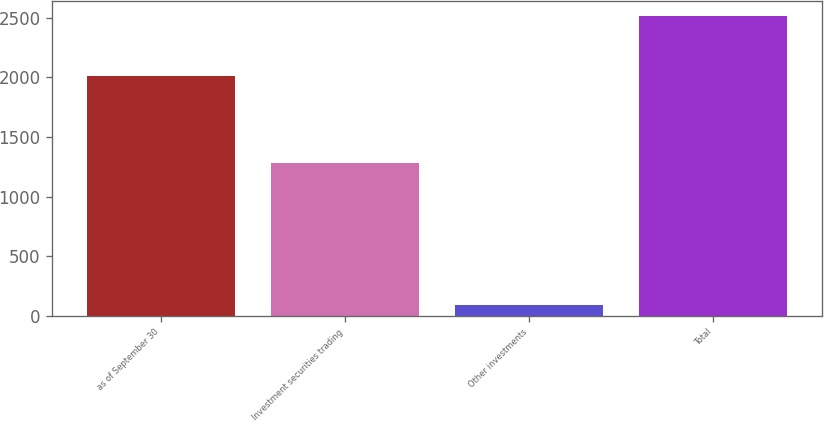Convert chart. <chart><loc_0><loc_0><loc_500><loc_500><bar_chart><fcel>as of September 30<fcel>Investment securities trading<fcel>Other investments<fcel>Total<nl><fcel>2014<fcel>1277.5<fcel>89.6<fcel>2516.1<nl></chart> 